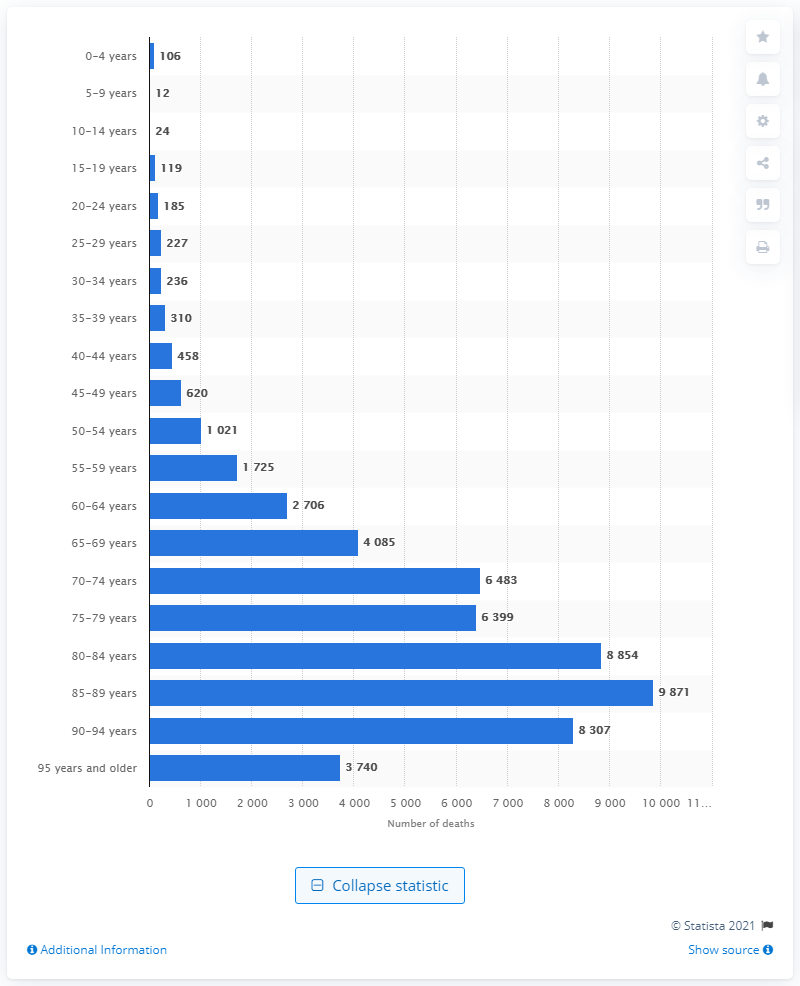List a handful of essential elements in this visual. In 2020, the number of people who died between the ages of 85 and 89 was 9,871. 